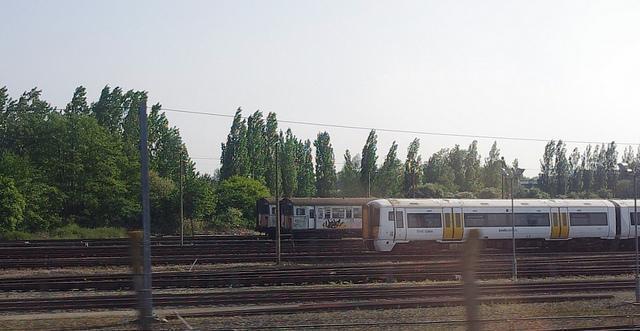How many trains can you see?
Give a very brief answer. 2. 